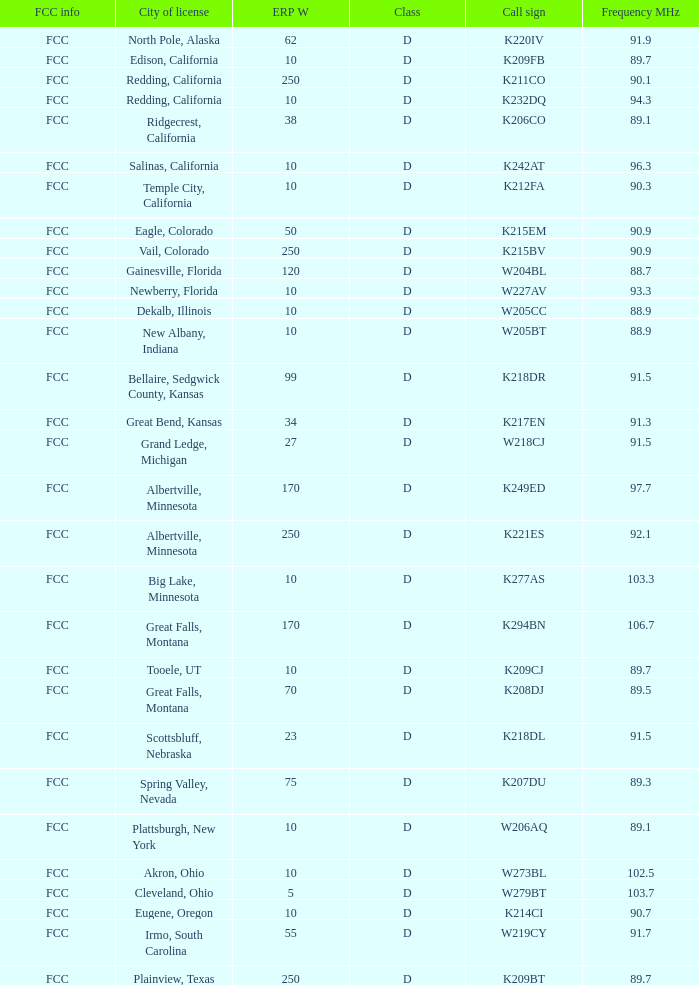Can you provide the call sign of the translator with an erp w over 38 and a city license originating from great falls, montana? K294BN, K208DJ. 